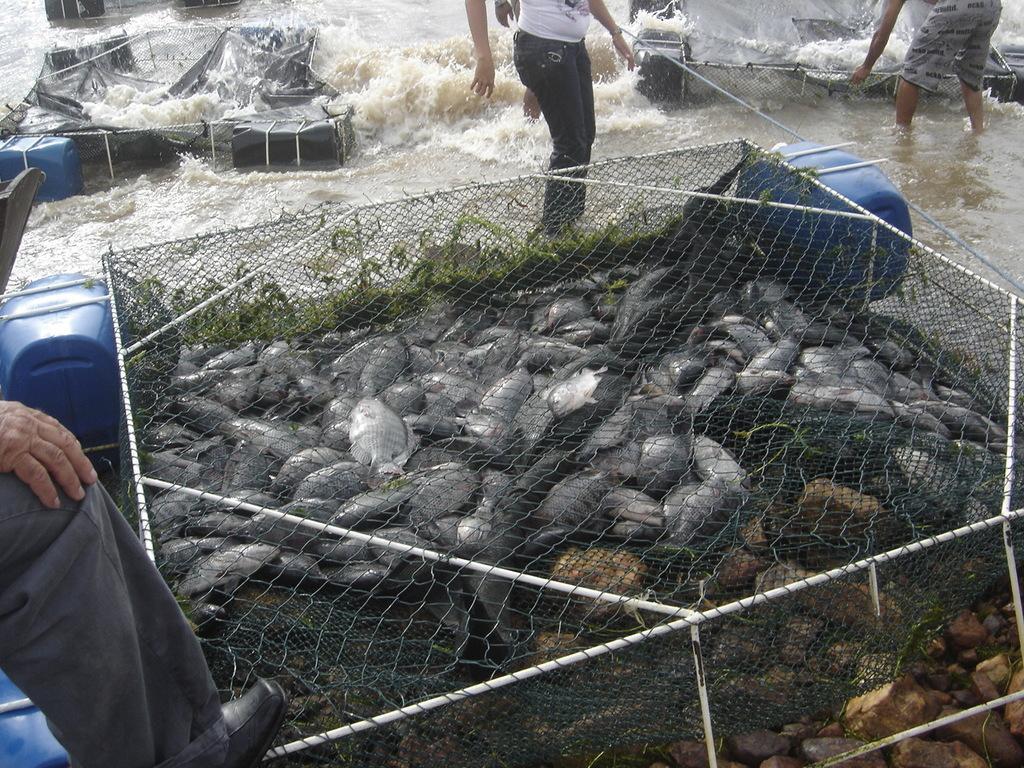Can you describe this image briefly? In this image, we can see fishes through the mesh. Here there are few people, water, few objects and things. 